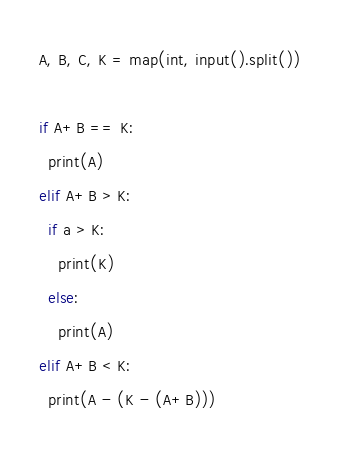<code> <loc_0><loc_0><loc_500><loc_500><_Python_>A, B, C, K = map(int, input().split())

if A+B == K:
  print(A)
elif A+B > K:
  if a > K:
    print(K)
  else:
    print(A)
elif A+B < K:
  print(A - (K - (A+B)))
</code> 